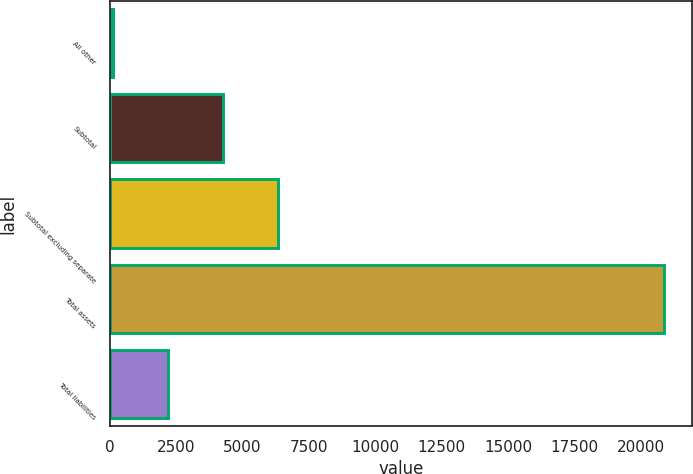Convert chart. <chart><loc_0><loc_0><loc_500><loc_500><bar_chart><fcel>All other<fcel>Subtotal<fcel>Subtotal excluding separate<fcel>Total assets<fcel>Total liabilities<nl><fcel>134<fcel>4282.6<fcel>6356.9<fcel>20877<fcel>2208.3<nl></chart> 